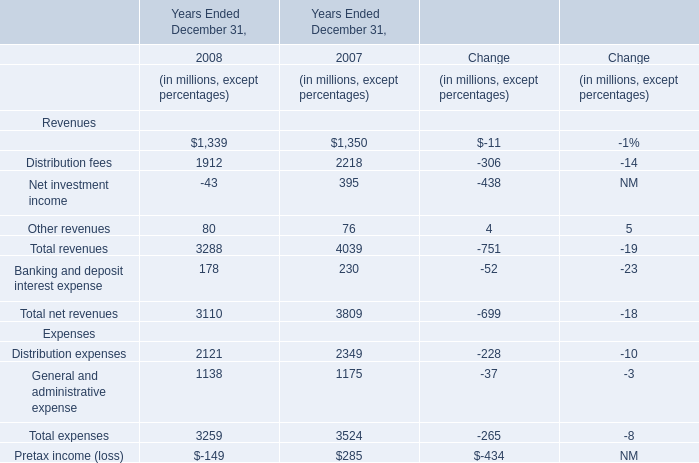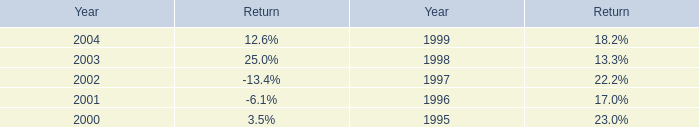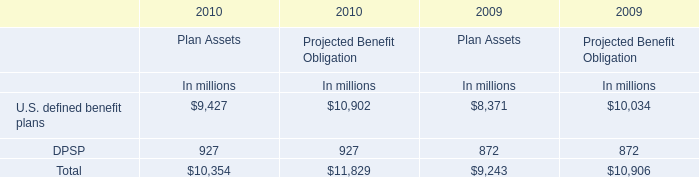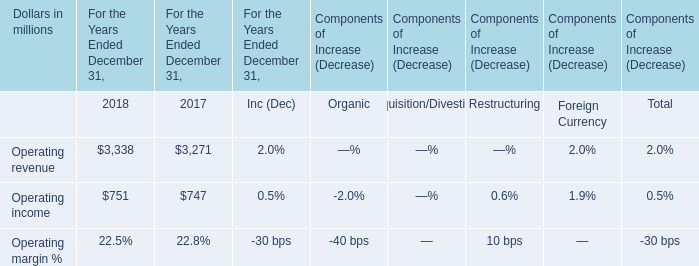What is the sum of the Revenues in the years / sections where Net investment income is positive? (in million) 
Answer: 4039. 